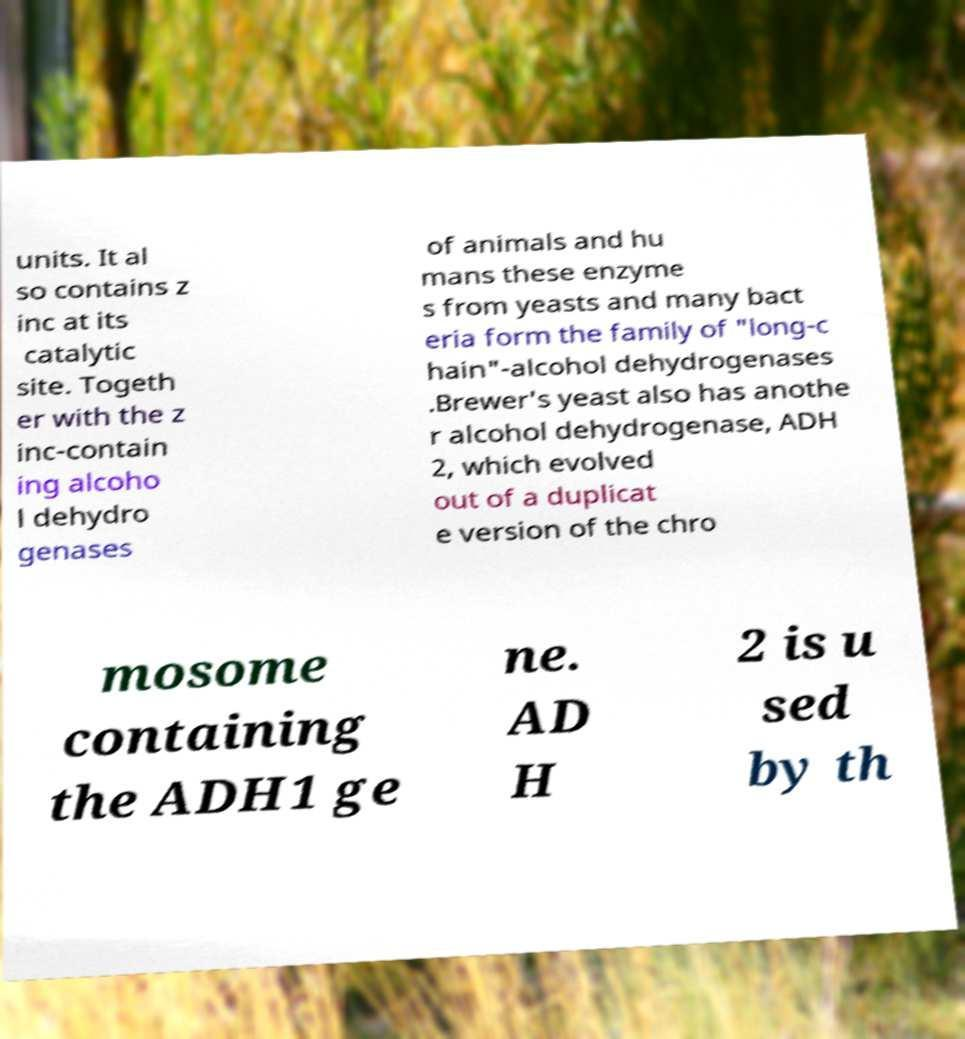Can you accurately transcribe the text from the provided image for me? units. It al so contains z inc at its catalytic site. Togeth er with the z inc-contain ing alcoho l dehydro genases of animals and hu mans these enzyme s from yeasts and many bact eria form the family of "long-c hain"-alcohol dehydrogenases .Brewer's yeast also has anothe r alcohol dehydrogenase, ADH 2, which evolved out of a duplicat e version of the chro mosome containing the ADH1 ge ne. AD H 2 is u sed by th 